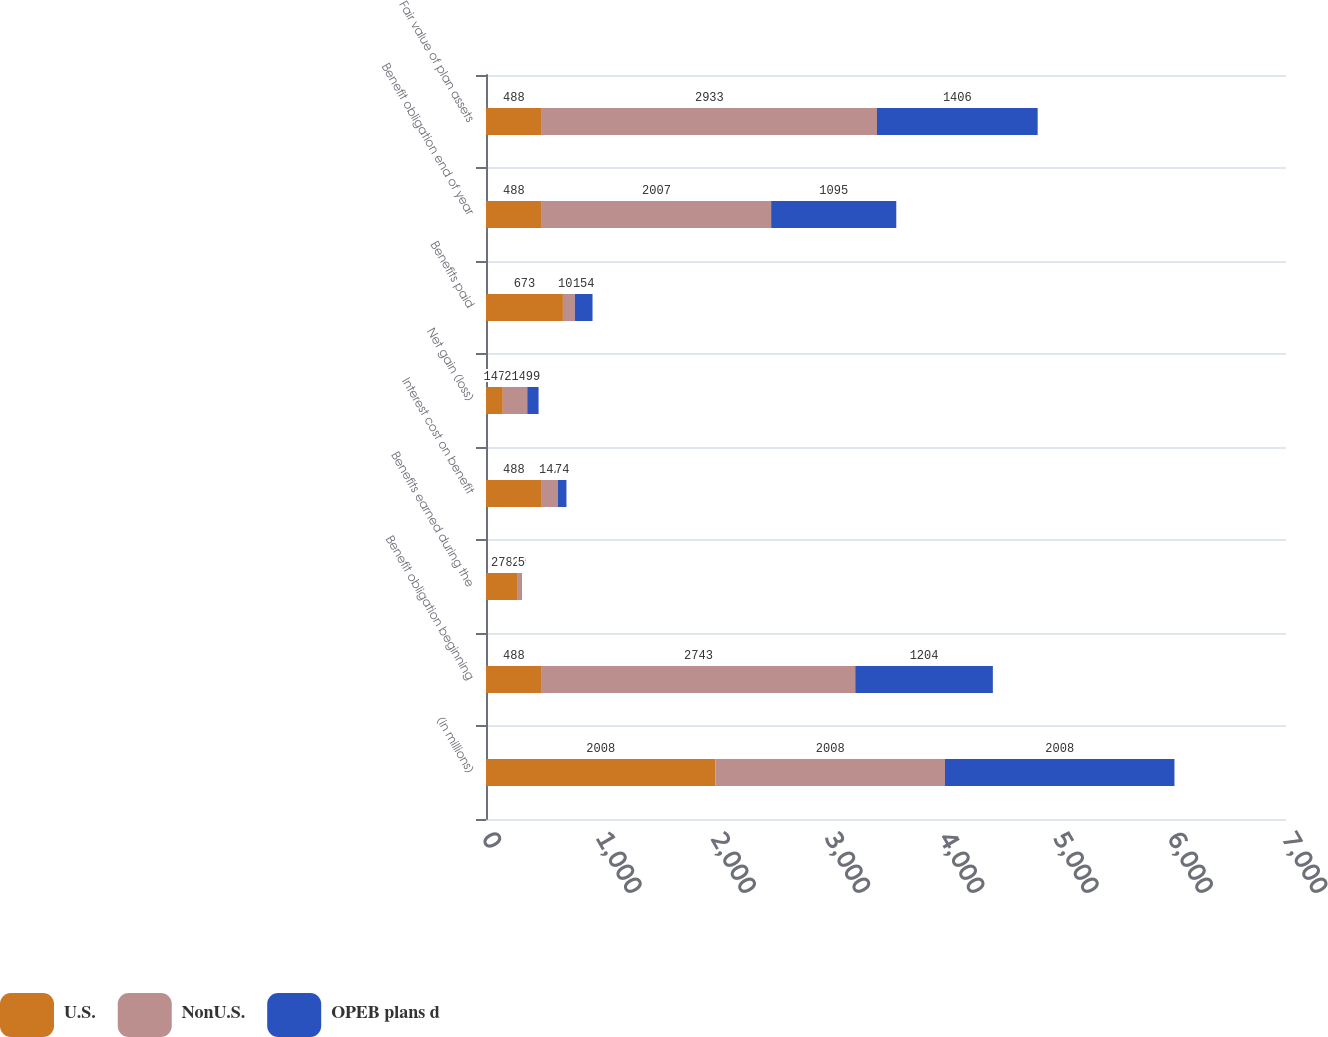Convert chart to OTSL. <chart><loc_0><loc_0><loc_500><loc_500><stacked_bar_chart><ecel><fcel>(in millions)<fcel>Benefit obligation beginning<fcel>Benefits earned during the<fcel>Interest cost on benefit<fcel>Net gain (loss)<fcel>Benefits paid<fcel>Benefit obligation end of year<fcel>Fair value of plan assets<nl><fcel>U.S.<fcel>2008<fcel>488<fcel>278<fcel>488<fcel>147<fcel>673<fcel>488<fcel>488<nl><fcel>NonU.S.<fcel>2008<fcel>2743<fcel>29<fcel>142<fcel>214<fcel>105<fcel>2007<fcel>2933<nl><fcel>OPEB plans d<fcel>2008<fcel>1204<fcel>5<fcel>74<fcel>99<fcel>154<fcel>1095<fcel>1406<nl></chart> 